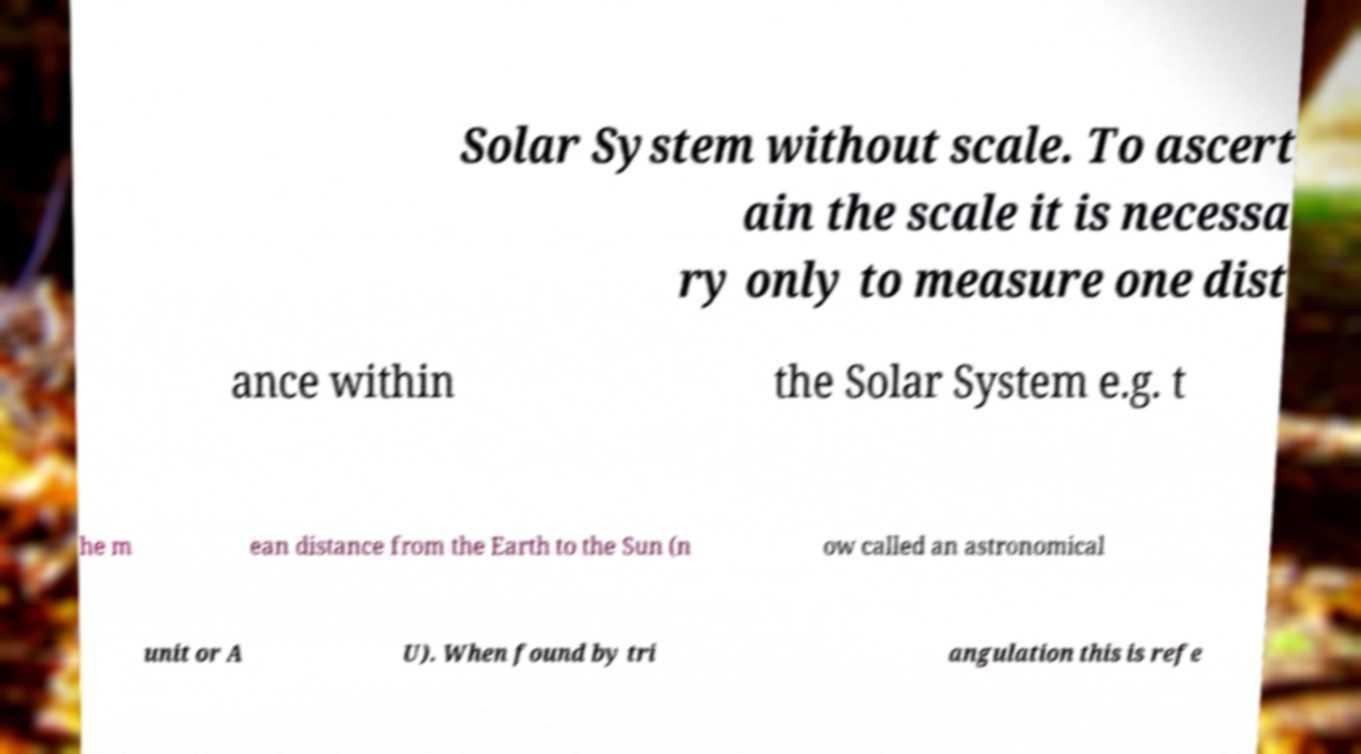For documentation purposes, I need the text within this image transcribed. Could you provide that? Solar System without scale. To ascert ain the scale it is necessa ry only to measure one dist ance within the Solar System e.g. t he m ean distance from the Earth to the Sun (n ow called an astronomical unit or A U). When found by tri angulation this is refe 